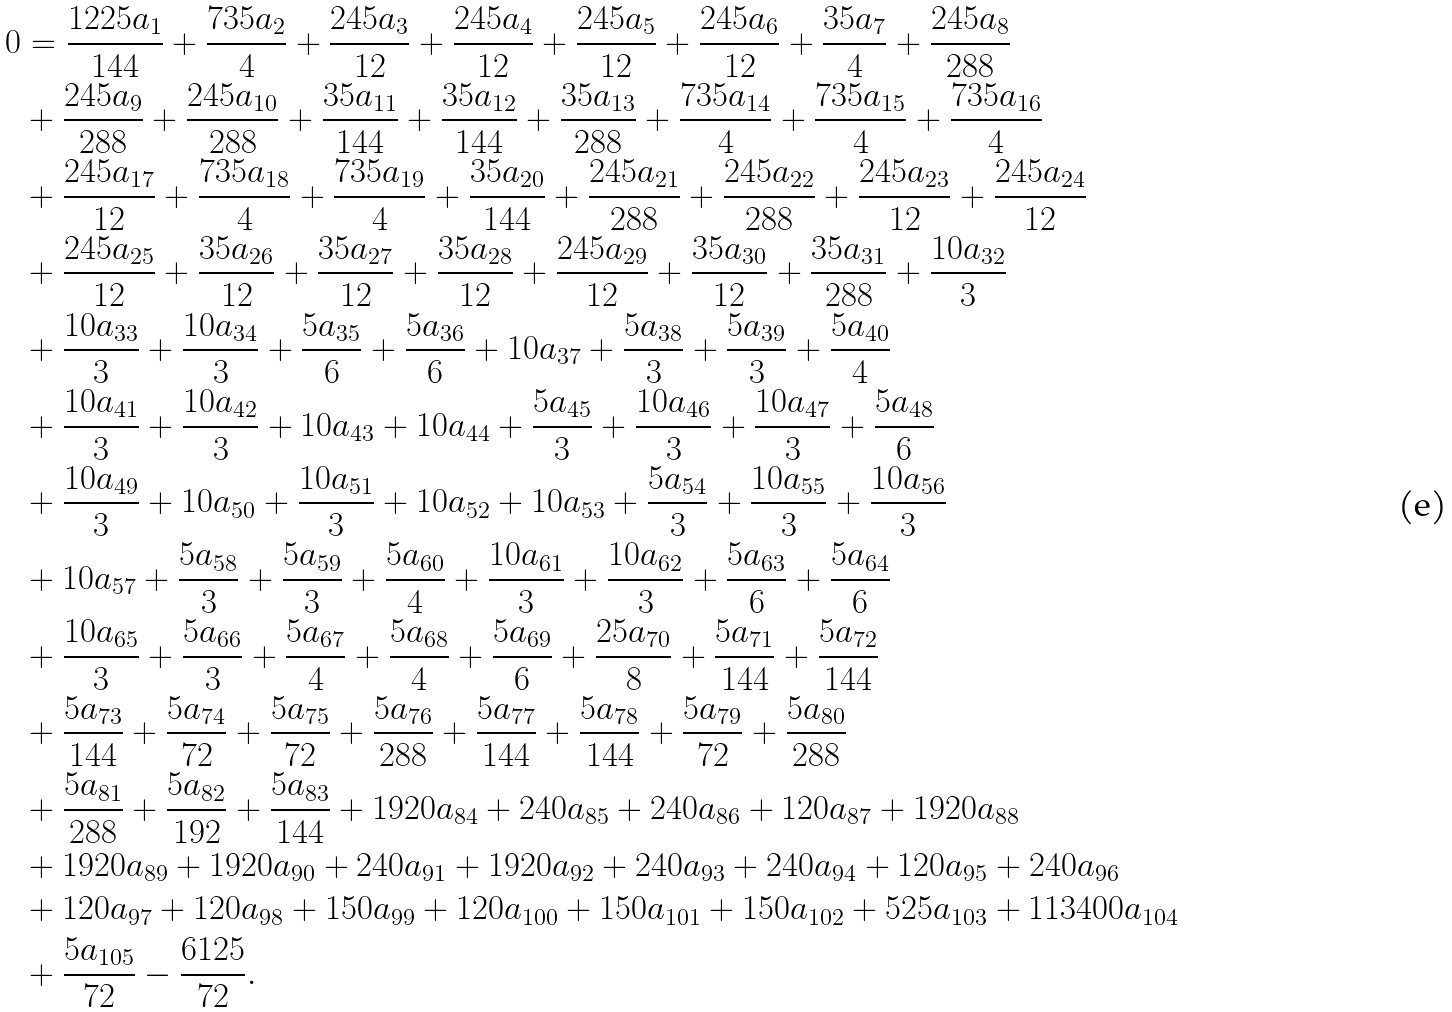Convert formula to latex. <formula><loc_0><loc_0><loc_500><loc_500>0 & = \frac { 1 2 2 5 a _ { 1 } } { 1 4 4 } + \frac { 7 3 5 a _ { 2 } } { 4 } + \frac { 2 4 5 a _ { 3 } } { 1 2 } + \frac { 2 4 5 a _ { 4 } } { 1 2 } + \frac { 2 4 5 a _ { 5 } } { 1 2 } + \frac { 2 4 5 a _ { 6 } } { 1 2 } + \frac { 3 5 a _ { 7 } } { 4 } + \frac { 2 4 5 a _ { 8 } } { 2 8 8 } \\ & + \frac { 2 4 5 a _ { 9 } } { 2 8 8 } + \frac { 2 4 5 a _ { 1 0 } } { 2 8 8 } + \frac { 3 5 a _ { 1 1 } } { 1 4 4 } + \frac { 3 5 a _ { 1 2 } } { 1 4 4 } + \frac { 3 5 a _ { 1 3 } } { 2 8 8 } + \frac { 7 3 5 a _ { 1 4 } } { 4 } + \frac { 7 3 5 a _ { 1 5 } } { 4 } + \frac { 7 3 5 a _ { 1 6 } } { 4 } \\ & + \frac { 2 4 5 a _ { 1 7 } } { 1 2 } + \frac { 7 3 5 a _ { 1 8 } } { 4 } + \frac { 7 3 5 a _ { 1 9 } } { 4 } + \frac { 3 5 a _ { 2 0 } } { 1 4 4 } + \frac { 2 4 5 a _ { 2 1 } } { 2 8 8 } + \frac { 2 4 5 a _ { 2 2 } } { 2 8 8 } + \frac { 2 4 5 a _ { 2 3 } } { 1 2 } + \frac { 2 4 5 a _ { 2 4 } } { 1 2 } \\ & + \frac { 2 4 5 a _ { 2 5 } } { 1 2 } + \frac { 3 5 a _ { 2 6 } } { 1 2 } + \frac { 3 5 a _ { 2 7 } } { 1 2 } + \frac { 3 5 a _ { 2 8 } } { 1 2 } + \frac { 2 4 5 a _ { 2 9 } } { 1 2 } + \frac { 3 5 a _ { 3 0 } } { 1 2 } + \frac { 3 5 a _ { 3 1 } } { 2 8 8 } + \frac { 1 0 a _ { 3 2 } } { 3 } \\ & + \frac { 1 0 a _ { 3 3 } } { 3 } + \frac { 1 0 a _ { 3 4 } } { 3 } + \frac { 5 a _ { 3 5 } } { 6 } + \frac { 5 a _ { 3 6 } } { 6 } + 1 0 a _ { 3 7 } + \frac { 5 a _ { 3 8 } } { 3 } + \frac { 5 a _ { 3 9 } } { 3 } + \frac { 5 a _ { 4 0 } } { 4 } \\ & + \frac { 1 0 a _ { 4 1 } } { 3 } + \frac { 1 0 a _ { 4 2 } } { 3 } + 1 0 a _ { 4 3 } + 1 0 a _ { 4 4 } + \frac { 5 a _ { 4 5 } } { 3 } + \frac { 1 0 a _ { 4 6 } } { 3 } + \frac { 1 0 a _ { 4 7 } } { 3 } + \frac { 5 a _ { 4 8 } } { 6 } \\ & + \frac { 1 0 a _ { 4 9 } } { 3 } + 1 0 a _ { 5 0 } + \frac { 1 0 a _ { 5 1 } } { 3 } + 1 0 a _ { 5 2 } + 1 0 a _ { 5 3 } + \frac { 5 a _ { 5 4 } } { 3 } + \frac { 1 0 a _ { 5 5 } } { 3 } + \frac { 1 0 a _ { 5 6 } } { 3 } \\ & + 1 0 a _ { 5 7 } + \frac { 5 a _ { 5 8 } } { 3 } + \frac { 5 a _ { 5 9 } } { 3 } + \frac { 5 a _ { 6 0 } } { 4 } + \frac { 1 0 a _ { 6 1 } } { 3 } + \frac { 1 0 a _ { 6 2 } } { 3 } + \frac { 5 a _ { 6 3 } } { 6 } + \frac { 5 a _ { 6 4 } } { 6 } \\ & + \frac { 1 0 a _ { 6 5 } } { 3 } + \frac { 5 a _ { 6 6 } } { 3 } + \frac { 5 a _ { 6 7 } } { 4 } + \frac { 5 a _ { 6 8 } } { 4 } + \frac { 5 a _ { 6 9 } } { 6 } + \frac { 2 5 a _ { 7 0 } } { 8 } + \frac { 5 a _ { 7 1 } } { 1 4 4 } + \frac { 5 a _ { 7 2 } } { 1 4 4 } \\ & + \frac { 5 a _ { 7 3 } } { 1 4 4 } + \frac { 5 a _ { 7 4 } } { 7 2 } + \frac { 5 a _ { 7 5 } } { 7 2 } + \frac { 5 a _ { 7 6 } } { 2 8 8 } + \frac { 5 a _ { 7 7 } } { 1 4 4 } + \frac { 5 a _ { 7 8 } } { 1 4 4 } + \frac { 5 a _ { 7 9 } } { 7 2 } + \frac { 5 a _ { 8 0 } } { 2 8 8 } \\ & + \frac { 5 a _ { 8 1 } } { 2 8 8 } + \frac { 5 a _ { 8 2 } } { 1 9 2 } + \frac { 5 a _ { 8 3 } } { 1 4 4 } + 1 9 2 0 a _ { 8 4 } + 2 4 0 a _ { 8 5 } + 2 4 0 a _ { 8 6 } + 1 2 0 a _ { 8 7 } + 1 9 2 0 a _ { 8 8 } \\ & + 1 9 2 0 a _ { 8 9 } + 1 9 2 0 a _ { 9 0 } + 2 4 0 a _ { 9 1 } + 1 9 2 0 a _ { 9 2 } + 2 4 0 a _ { 9 3 } + 2 4 0 a _ { 9 4 } + 1 2 0 a _ { 9 5 } + 2 4 0 a _ { 9 6 } \\ & + 1 2 0 a _ { 9 7 } + 1 2 0 a _ { 9 8 } + 1 5 0 a _ { 9 9 } + 1 2 0 a _ { 1 0 0 } + 1 5 0 a _ { 1 0 1 } + 1 5 0 a _ { 1 0 2 } + 5 2 5 a _ { 1 0 3 } + 1 1 3 4 0 0 a _ { 1 0 4 } \\ & + \frac { 5 a _ { 1 0 5 } } { 7 2 } - \frac { 6 1 2 5 } { 7 2 } .</formula> 